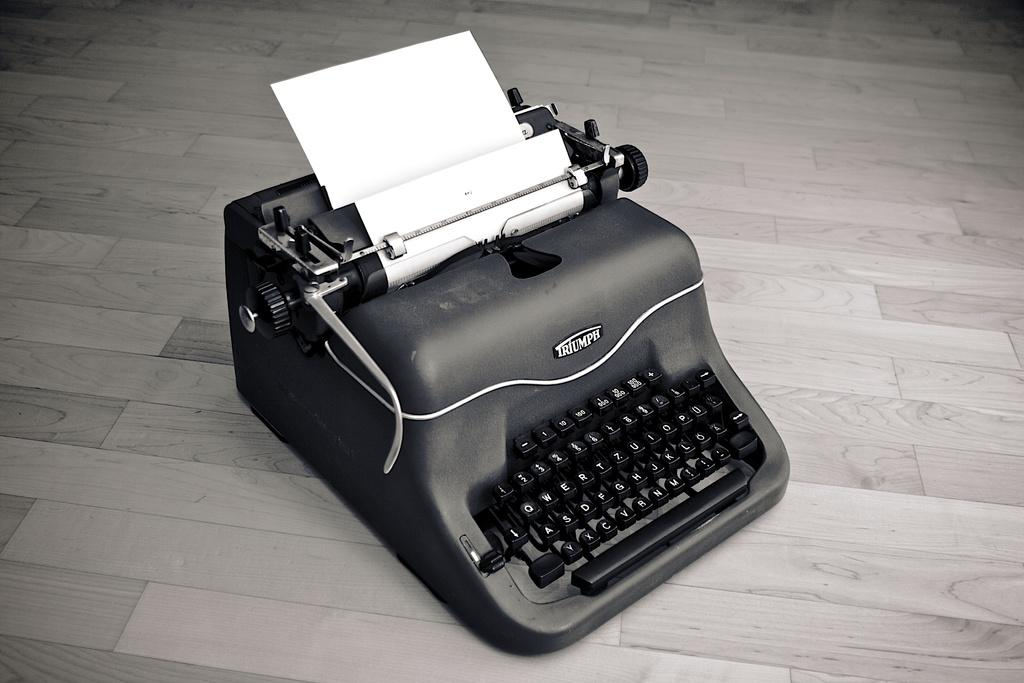<image>
Relay a brief, clear account of the picture shown. An old fashioned black typewriter by Triumph with a piece of white paper in the typewriter. 